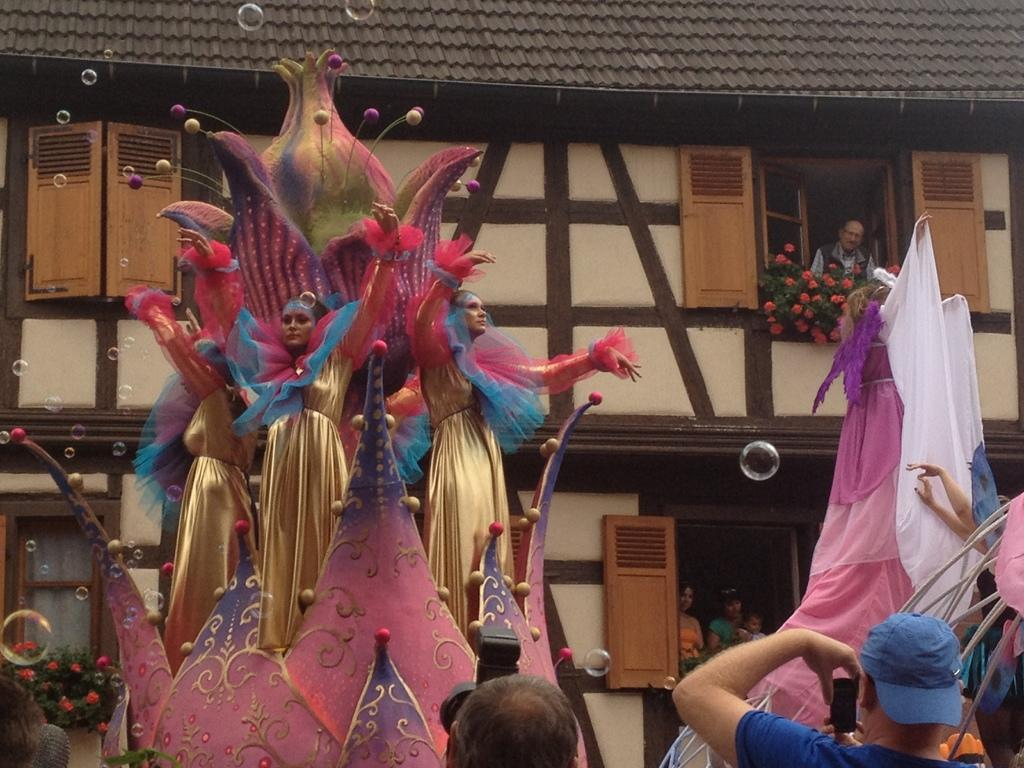What type of structure is visible in the image? There is a building in the image. What type of plants can be seen in the image? There are flowers in the image. What is the man in the image doing? The man is looking from a window in the image. What type of visual effect is present in the image? Water bubbles are visible in the image. What is the woman in the image doing? The woman is standing in a decor in the image. What type of architectural feature is present in the image? Walls are present in the image. How does the person in the image say good-bye? There is no person present in the image; only a man and a woman are mentioned. What type of copy machine is visible in the image? There is no copy machine present in the image. 